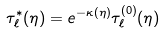Convert formula to latex. <formula><loc_0><loc_0><loc_500><loc_500>\tau _ { \ell } ^ { * } ( \eta ) = e ^ { - \kappa ( \eta ) } \tau _ { \ell } ^ { ( 0 ) } ( \eta )</formula> 